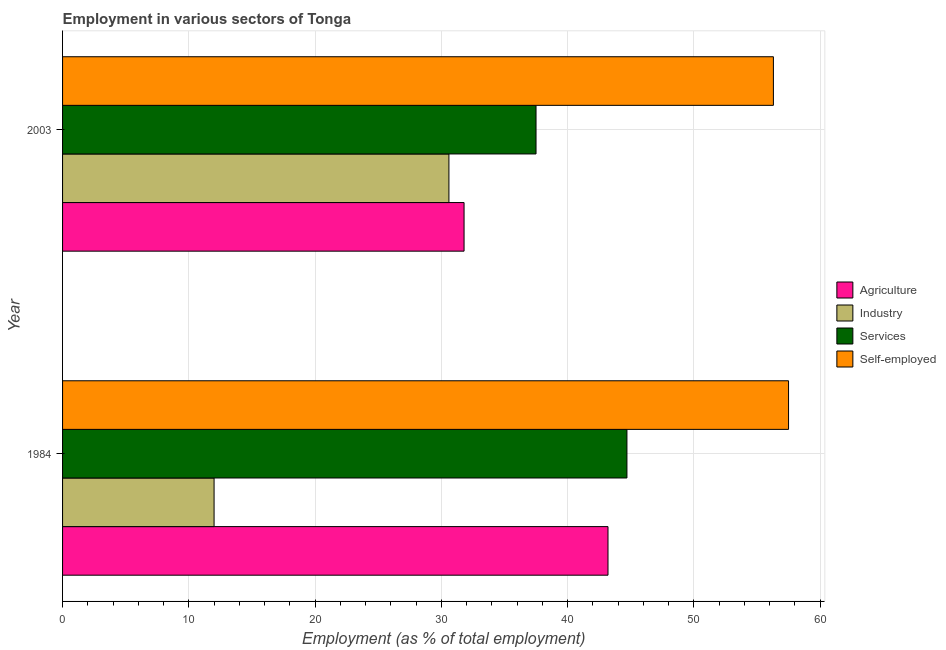How many different coloured bars are there?
Make the answer very short. 4. How many groups of bars are there?
Offer a terse response. 2. Are the number of bars on each tick of the Y-axis equal?
Give a very brief answer. Yes. How many bars are there on the 1st tick from the top?
Provide a short and direct response. 4. How many bars are there on the 2nd tick from the bottom?
Ensure brevity in your answer.  4. What is the label of the 2nd group of bars from the top?
Your response must be concise. 1984. In how many cases, is the number of bars for a given year not equal to the number of legend labels?
Your answer should be compact. 0. What is the percentage of workers in agriculture in 1984?
Offer a very short reply. 43.2. Across all years, what is the maximum percentage of workers in services?
Make the answer very short. 44.7. Across all years, what is the minimum percentage of self employed workers?
Offer a terse response. 56.3. In which year was the percentage of workers in agriculture maximum?
Offer a very short reply. 1984. What is the total percentage of workers in services in the graph?
Provide a succinct answer. 82.2. What is the difference between the percentage of workers in agriculture in 1984 and that in 2003?
Ensure brevity in your answer.  11.4. What is the difference between the percentage of workers in services in 2003 and the percentage of workers in agriculture in 1984?
Provide a succinct answer. -5.7. What is the average percentage of workers in industry per year?
Your answer should be compact. 21.3. In the year 1984, what is the difference between the percentage of self employed workers and percentage of workers in agriculture?
Keep it short and to the point. 14.3. In how many years, is the percentage of self employed workers greater than 34 %?
Your answer should be compact. 2. What is the ratio of the percentage of workers in agriculture in 1984 to that in 2003?
Give a very brief answer. 1.36. Is the percentage of workers in services in 1984 less than that in 2003?
Offer a very short reply. No. Is it the case that in every year, the sum of the percentage of workers in agriculture and percentage of workers in industry is greater than the sum of percentage of workers in services and percentage of self employed workers?
Provide a succinct answer. Yes. What does the 3rd bar from the top in 1984 represents?
Your answer should be very brief. Industry. What does the 2nd bar from the bottom in 2003 represents?
Make the answer very short. Industry. How many bars are there?
Provide a short and direct response. 8. Are all the bars in the graph horizontal?
Keep it short and to the point. Yes. What is the difference between two consecutive major ticks on the X-axis?
Your answer should be very brief. 10. Does the graph contain any zero values?
Offer a terse response. No. Does the graph contain grids?
Provide a succinct answer. Yes. How many legend labels are there?
Offer a terse response. 4. What is the title of the graph?
Make the answer very short. Employment in various sectors of Tonga. Does "Taxes on goods and services" appear as one of the legend labels in the graph?
Ensure brevity in your answer.  No. What is the label or title of the X-axis?
Your answer should be compact. Employment (as % of total employment). What is the label or title of the Y-axis?
Make the answer very short. Year. What is the Employment (as % of total employment) of Agriculture in 1984?
Ensure brevity in your answer.  43.2. What is the Employment (as % of total employment) in Industry in 1984?
Provide a succinct answer. 12. What is the Employment (as % of total employment) in Services in 1984?
Make the answer very short. 44.7. What is the Employment (as % of total employment) of Self-employed in 1984?
Offer a terse response. 57.5. What is the Employment (as % of total employment) of Agriculture in 2003?
Make the answer very short. 31.8. What is the Employment (as % of total employment) in Industry in 2003?
Keep it short and to the point. 30.6. What is the Employment (as % of total employment) of Services in 2003?
Provide a short and direct response. 37.5. What is the Employment (as % of total employment) of Self-employed in 2003?
Offer a terse response. 56.3. Across all years, what is the maximum Employment (as % of total employment) of Agriculture?
Ensure brevity in your answer.  43.2. Across all years, what is the maximum Employment (as % of total employment) in Industry?
Keep it short and to the point. 30.6. Across all years, what is the maximum Employment (as % of total employment) of Services?
Keep it short and to the point. 44.7. Across all years, what is the maximum Employment (as % of total employment) of Self-employed?
Provide a succinct answer. 57.5. Across all years, what is the minimum Employment (as % of total employment) in Agriculture?
Make the answer very short. 31.8. Across all years, what is the minimum Employment (as % of total employment) in Industry?
Provide a succinct answer. 12. Across all years, what is the minimum Employment (as % of total employment) in Services?
Offer a very short reply. 37.5. Across all years, what is the minimum Employment (as % of total employment) in Self-employed?
Ensure brevity in your answer.  56.3. What is the total Employment (as % of total employment) of Industry in the graph?
Ensure brevity in your answer.  42.6. What is the total Employment (as % of total employment) in Services in the graph?
Provide a short and direct response. 82.2. What is the total Employment (as % of total employment) in Self-employed in the graph?
Offer a very short reply. 113.8. What is the difference between the Employment (as % of total employment) of Agriculture in 1984 and that in 2003?
Make the answer very short. 11.4. What is the difference between the Employment (as % of total employment) of Industry in 1984 and that in 2003?
Make the answer very short. -18.6. What is the difference between the Employment (as % of total employment) of Agriculture in 1984 and the Employment (as % of total employment) of Services in 2003?
Give a very brief answer. 5.7. What is the difference between the Employment (as % of total employment) in Agriculture in 1984 and the Employment (as % of total employment) in Self-employed in 2003?
Provide a succinct answer. -13.1. What is the difference between the Employment (as % of total employment) in Industry in 1984 and the Employment (as % of total employment) in Services in 2003?
Give a very brief answer. -25.5. What is the difference between the Employment (as % of total employment) of Industry in 1984 and the Employment (as % of total employment) of Self-employed in 2003?
Your answer should be very brief. -44.3. What is the difference between the Employment (as % of total employment) in Services in 1984 and the Employment (as % of total employment) in Self-employed in 2003?
Give a very brief answer. -11.6. What is the average Employment (as % of total employment) of Agriculture per year?
Keep it short and to the point. 37.5. What is the average Employment (as % of total employment) in Industry per year?
Make the answer very short. 21.3. What is the average Employment (as % of total employment) in Services per year?
Provide a short and direct response. 41.1. What is the average Employment (as % of total employment) in Self-employed per year?
Your answer should be compact. 56.9. In the year 1984, what is the difference between the Employment (as % of total employment) of Agriculture and Employment (as % of total employment) of Industry?
Provide a short and direct response. 31.2. In the year 1984, what is the difference between the Employment (as % of total employment) in Agriculture and Employment (as % of total employment) in Self-employed?
Offer a very short reply. -14.3. In the year 1984, what is the difference between the Employment (as % of total employment) in Industry and Employment (as % of total employment) in Services?
Your response must be concise. -32.7. In the year 1984, what is the difference between the Employment (as % of total employment) in Industry and Employment (as % of total employment) in Self-employed?
Offer a very short reply. -45.5. In the year 1984, what is the difference between the Employment (as % of total employment) of Services and Employment (as % of total employment) of Self-employed?
Keep it short and to the point. -12.8. In the year 2003, what is the difference between the Employment (as % of total employment) in Agriculture and Employment (as % of total employment) in Industry?
Provide a succinct answer. 1.2. In the year 2003, what is the difference between the Employment (as % of total employment) in Agriculture and Employment (as % of total employment) in Services?
Your answer should be very brief. -5.7. In the year 2003, what is the difference between the Employment (as % of total employment) of Agriculture and Employment (as % of total employment) of Self-employed?
Your response must be concise. -24.5. In the year 2003, what is the difference between the Employment (as % of total employment) in Industry and Employment (as % of total employment) in Self-employed?
Make the answer very short. -25.7. In the year 2003, what is the difference between the Employment (as % of total employment) in Services and Employment (as % of total employment) in Self-employed?
Offer a very short reply. -18.8. What is the ratio of the Employment (as % of total employment) in Agriculture in 1984 to that in 2003?
Offer a terse response. 1.36. What is the ratio of the Employment (as % of total employment) of Industry in 1984 to that in 2003?
Ensure brevity in your answer.  0.39. What is the ratio of the Employment (as % of total employment) of Services in 1984 to that in 2003?
Make the answer very short. 1.19. What is the ratio of the Employment (as % of total employment) of Self-employed in 1984 to that in 2003?
Make the answer very short. 1.02. What is the difference between the highest and the second highest Employment (as % of total employment) in Agriculture?
Your answer should be compact. 11.4. What is the difference between the highest and the second highest Employment (as % of total employment) of Industry?
Your answer should be very brief. 18.6. What is the difference between the highest and the lowest Employment (as % of total employment) in Agriculture?
Keep it short and to the point. 11.4. What is the difference between the highest and the lowest Employment (as % of total employment) in Industry?
Provide a short and direct response. 18.6. What is the difference between the highest and the lowest Employment (as % of total employment) in Services?
Provide a succinct answer. 7.2. 